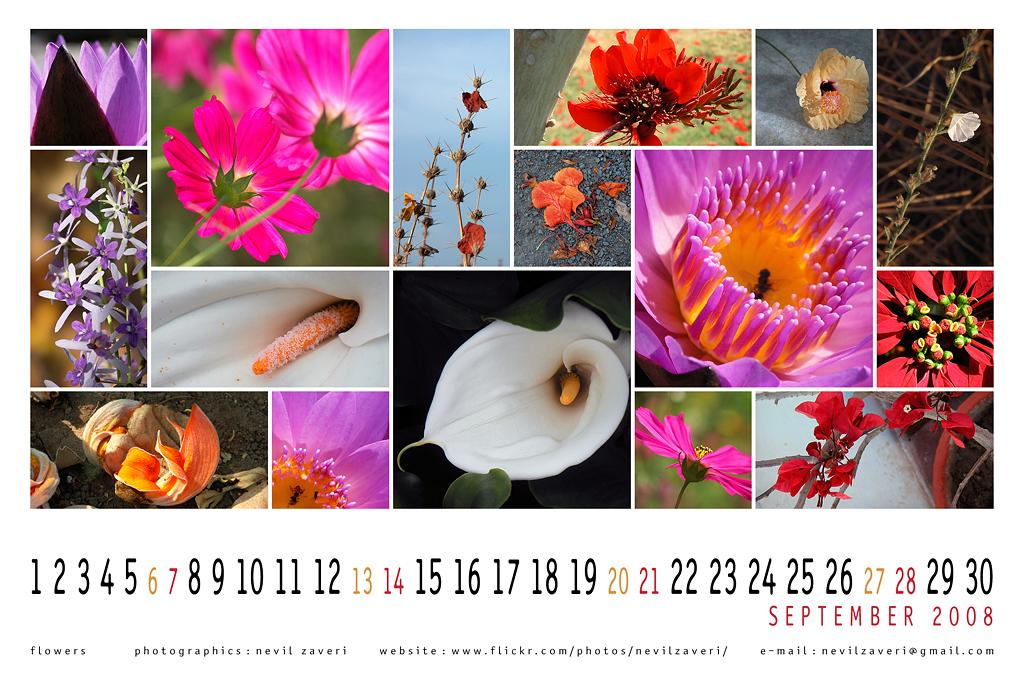What is the main subject of the image? The main subject of the image is a poster. What is depicted on the poster? The poster has different types of flowers. What can be observed about the flowers on the poster? The flowers are in different colors. What additional information is provided on the poster? There is a calendar at the bottom of the poster. How much waste is being generated by the flowers in the image? There is no indication of waste generation in the image, as it features a poster with flowers and a calendar. --- Facts: 1. There is a person in the image. 2. The person is wearing a hat. 3. The person is holding a book. 4. There is a table in the image. 5. The table has a lamp on it. Absurd Topics: ocean, dance, animal Conversation: Who is the main subject of the image? The main subject of the image is a person. What is the person wearing in the image? The person is wearing a hat. What is the person holding in the image? The person is holding a book. What object is present on the table in the image? There is a lamp on the table in the image. Reasoning: Let's think step by step in order to produce the conversation. We start by identifying the main subject of the image, which is the person. Then, we describe the person's attire and what they are holding. Finally, we mention the presence of a table and a lamp on it. Absurd Question/Answer: Can you see any animals dancing in the ocean in the image? There is no ocean, dance, or animal present in the image; it features a person wearing a hat, holding a book, and standing near a table with a lamp on it. 